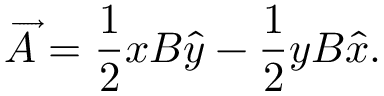<formula> <loc_0><loc_0><loc_500><loc_500>\overrightarrow { A } = \frac { 1 } { 2 } x B \widehat { y } - \frac { 1 } { 2 } y B \widehat { x } .</formula> 